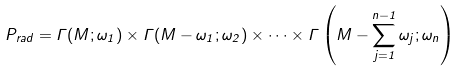<formula> <loc_0><loc_0><loc_500><loc_500>P _ { r a d } = \Gamma ( M ; \omega _ { 1 } ) \times \Gamma ( M - \omega _ { 1 } ; \omega _ { 2 } ) \times \dots \times \Gamma \left ( M - \sum _ { j = 1 } ^ { n - 1 } \omega _ { j } ; \omega _ { n } \right )</formula> 